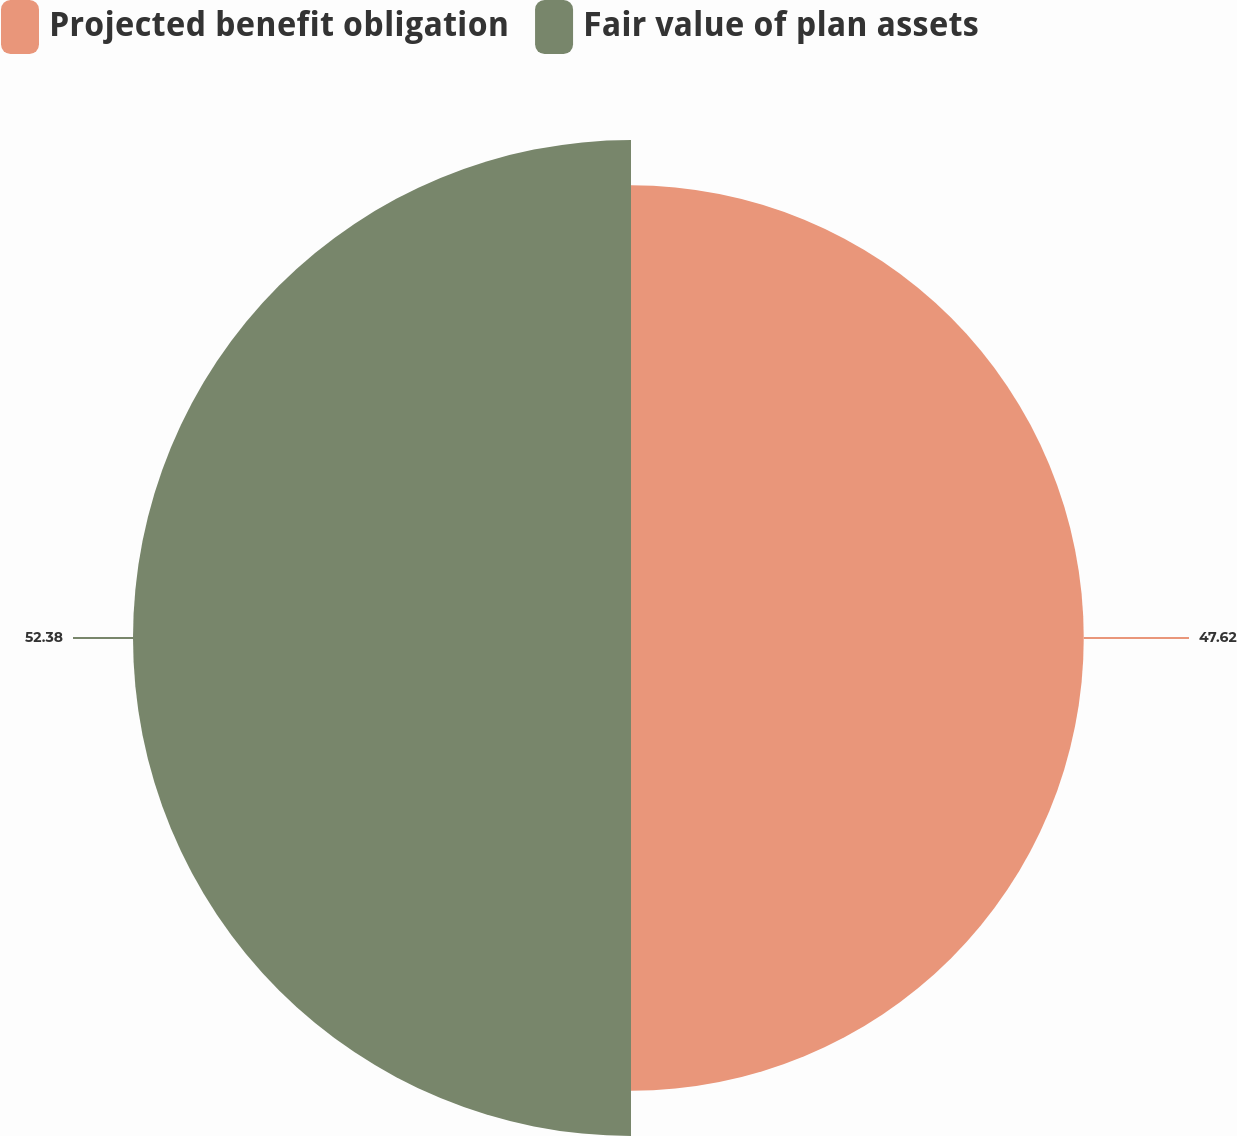<chart> <loc_0><loc_0><loc_500><loc_500><pie_chart><fcel>Projected benefit obligation<fcel>Fair value of plan assets<nl><fcel>47.62%<fcel>52.38%<nl></chart> 